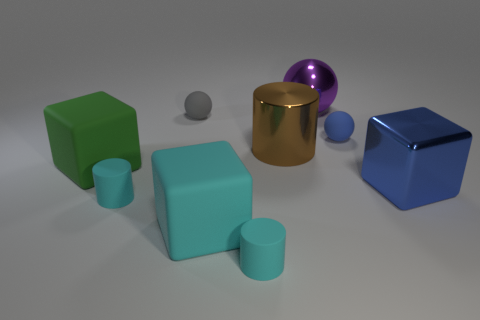Which objects in the image can stack on top of each other? The metallic gold cylinder and the small lavender sphere could be stacked on top of both the green and blue cubes due to their flat surfaces. 